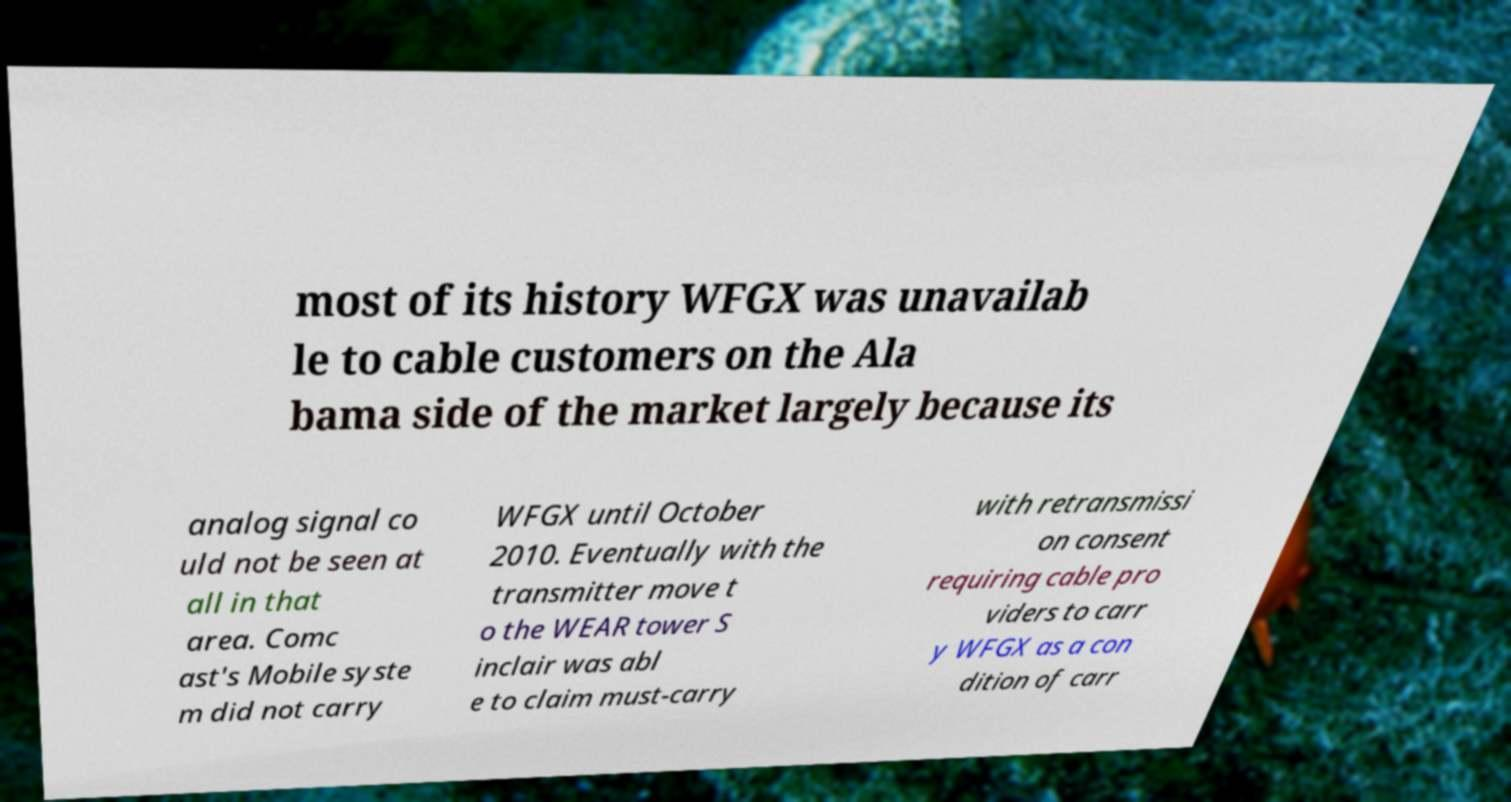I need the written content from this picture converted into text. Can you do that? most of its history WFGX was unavailab le to cable customers on the Ala bama side of the market largely because its analog signal co uld not be seen at all in that area. Comc ast's Mobile syste m did not carry WFGX until October 2010. Eventually with the transmitter move t o the WEAR tower S inclair was abl e to claim must-carry with retransmissi on consent requiring cable pro viders to carr y WFGX as a con dition of carr 